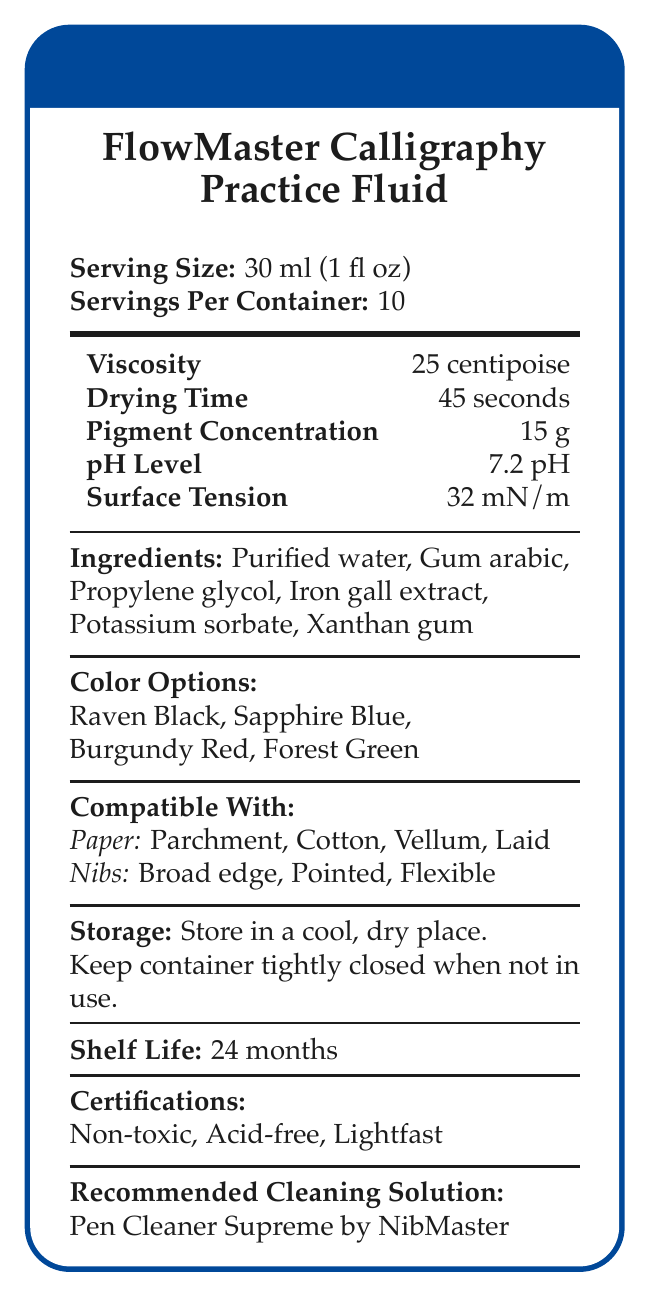what is the serving size? The serving size is mentioned explicitly in the document.
Answer: 30 ml (1 fl oz) what are the ingredients in the FlowMaster Calligraphy Practice Fluid? The ingredients are listed under the "Ingredients" section.
Answer: Purified water, Gum arabic, Propylene glycol, Iron gall extract, Potassium sorbate, Xanthan gum what is the recommended cleaning solution? The recommended cleaning solution is mentioned under the "Recommended Cleaning Solution" section.
Answer: Pen Cleaner Supreme by NibMaster how many servings are in one container? The number of servings per container is mentioned.
Answer: 10 what is the viscosity of the calligraphy practice fluid? The viscosity value is listed in the Viscosity section.
Answer: 25 centipoise which ingredient is present in the highest concentration? The document provides the list of ingredients but does not specify concentrations for each.
Answer: Cannot be determined what is the pH level of the practice fluid? The pH level is listed under the pH Level section.
Answer: 7.2 pH which paper types are compatible with the practice fluid? A. Paper: Parchment, Cotton, Laid, Bond B. Paper: Parchment, Cotton, Vellum, Laid C. Paper: Rice, Cotton, Vellum, Laid The document lists Parchment, Cotton, Vellum, and Laid as compatible paper types.
Answer: B how long is the shelf life of the practice fluid? The shelf life is mentioned in the "Shelf Life" section.
Answer: 24 months which of the following is NOT a color option for the practice fluid? A. Raven Black B. Sapphire Blue C. Amber Yellow D. Forest Green The document lists Raven Black, Sapphire Blue, Burgundy Red, and Forest Green as color options; Amber Yellow is not listed.
Answer: C is the FlowMaster Calligraphy Practice Fluid considered lightfast? The document lists "Lightfast" under the Certifications section.
Answer: Yes summarize the main features of the FlowMaster Calligraphy Practice Fluid. The summary covers all key points regarding the product including its properties, compatibility, usage instructions, and certifications.
Answer: The FlowMaster Calligraphy Practice Fluid is a specialty fluid designed for calligraphy practice. It is non-toxic, acid-free, and lightfast with a serving size of 30 ml per use and 10 servings per container. Key properties include a viscosity of 25 centipoise, a drying time of 45 seconds, a pH level of 7.2, and a surface tension of 32 mN/m. It is compatible with various paper and nib types and is available in four colors. The fluid has a shelf life of 24 months and should be stored in a cool, dry place. Recommended cleaning solution is Pen Cleaner Supreme by NibMaster. what is the drying time for the practice fluid? The drying time is listed under the Drying Time section.
Answer: 45 seconds 